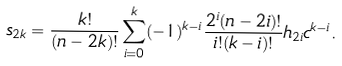Convert formula to latex. <formula><loc_0><loc_0><loc_500><loc_500>s _ { 2 k } = \frac { k ! } { ( n - 2 k ) ! } \sum _ { i = 0 } ^ { k } ( - 1 ) ^ { k - i } \frac { 2 ^ { i } ( n - 2 i ) ! } { i ! ( k - i ) ! } h _ { 2 i } c ^ { k - i } .</formula> 